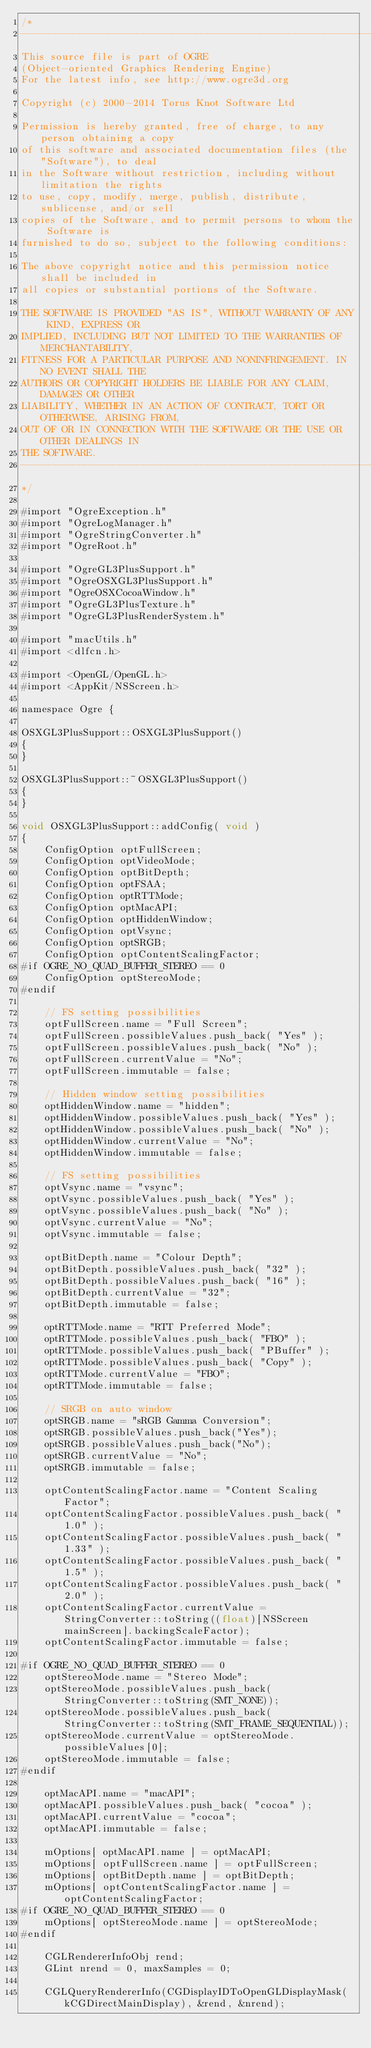<code> <loc_0><loc_0><loc_500><loc_500><_ObjectiveC_>/*
-----------------------------------------------------------------------------
This source file is part of OGRE
(Object-oriented Graphics Rendering Engine)
For the latest info, see http://www.ogre3d.org

Copyright (c) 2000-2014 Torus Knot Software Ltd

Permission is hereby granted, free of charge, to any person obtaining a copy
of this software and associated documentation files (the "Software"), to deal
in the Software without restriction, including without limitation the rights
to use, copy, modify, merge, publish, distribute, sublicense, and/or sell
copies of the Software, and to permit persons to whom the Software is
furnished to do so, subject to the following conditions:

The above copyright notice and this permission notice shall be included in
all copies or substantial portions of the Software.

THE SOFTWARE IS PROVIDED "AS IS", WITHOUT WARRANTY OF ANY KIND, EXPRESS OR
IMPLIED, INCLUDING BUT NOT LIMITED TO THE WARRANTIES OF MERCHANTABILITY,
FITNESS FOR A PARTICULAR PURPOSE AND NONINFRINGEMENT. IN NO EVENT SHALL THE
AUTHORS OR COPYRIGHT HOLDERS BE LIABLE FOR ANY CLAIM, DAMAGES OR OTHER
LIABILITY, WHETHER IN AN ACTION OF CONTRACT, TORT OR OTHERWISE, ARISING FROM,
OUT OF OR IN CONNECTION WITH THE SOFTWARE OR THE USE OR OTHER DEALINGS IN
THE SOFTWARE.
-----------------------------------------------------------------------------
*/

#import "OgreException.h"
#import "OgreLogManager.h"
#import "OgreStringConverter.h"
#import "OgreRoot.h"

#import "OgreGL3PlusSupport.h"
#import "OgreOSXGL3PlusSupport.h"
#import "OgreOSXCocoaWindow.h"
#import "OgreGL3PlusTexture.h"
#import "OgreGL3PlusRenderSystem.h"

#import "macUtils.h"
#import <dlfcn.h>

#import <OpenGL/OpenGL.h>
#import <AppKit/NSScreen.h>

namespace Ogre {

OSXGL3PlusSupport::OSXGL3PlusSupport()
{
}

OSXGL3PlusSupport::~OSXGL3PlusSupport()
{
}

void OSXGL3PlusSupport::addConfig( void )
{
	ConfigOption optFullScreen;
	ConfigOption optVideoMode;
	ConfigOption optBitDepth;
	ConfigOption optFSAA;
	ConfigOption optRTTMode;
    ConfigOption optMacAPI;
	ConfigOption optHiddenWindow;
	ConfigOption optVsync;
	ConfigOption optSRGB;
    ConfigOption optContentScalingFactor;
#if OGRE_NO_QUAD_BUFFER_STEREO == 0
	ConfigOption optStereoMode;
#endif

	// FS setting possibilities
	optFullScreen.name = "Full Screen";
	optFullScreen.possibleValues.push_back( "Yes" );
	optFullScreen.possibleValues.push_back( "No" );
	optFullScreen.currentValue = "No";
	optFullScreen.immutable = false;

    // Hidden window setting possibilities
	optHiddenWindow.name = "hidden";
	optHiddenWindow.possibleValues.push_back( "Yes" );
	optHiddenWindow.possibleValues.push_back( "No" );
	optHiddenWindow.currentValue = "No";
	optHiddenWindow.immutable = false;

    // FS setting possibilities
	optVsync.name = "vsync";
	optVsync.possibleValues.push_back( "Yes" );
	optVsync.possibleValues.push_back( "No" );
	optVsync.currentValue = "No";
	optVsync.immutable = false;

	optBitDepth.name = "Colour Depth";
	optBitDepth.possibleValues.push_back( "32" );
	optBitDepth.possibleValues.push_back( "16" );
	optBitDepth.currentValue = "32";
	optBitDepth.immutable = false;

    optRTTMode.name = "RTT Preferred Mode";
	optRTTMode.possibleValues.push_back( "FBO" );
	optRTTMode.possibleValues.push_back( "PBuffer" );
	optRTTMode.possibleValues.push_back( "Copy" );
	optRTTMode.currentValue = "FBO";
	optRTTMode.immutable = false;

	// SRGB on auto window
	optSRGB.name = "sRGB Gamma Conversion";
	optSRGB.possibleValues.push_back("Yes");
	optSRGB.possibleValues.push_back("No");
	optSRGB.currentValue = "No";
	optSRGB.immutable = false;

    optContentScalingFactor.name = "Content Scaling Factor";
    optContentScalingFactor.possibleValues.push_back( "1.0" );
    optContentScalingFactor.possibleValues.push_back( "1.33" );
    optContentScalingFactor.possibleValues.push_back( "1.5" );
    optContentScalingFactor.possibleValues.push_back( "2.0" );
    optContentScalingFactor.currentValue = StringConverter::toString((float)[NSScreen mainScreen].backingScaleFactor);
    optContentScalingFactor.immutable = false;

#if OGRE_NO_QUAD_BUFFER_STEREO == 0
	optStereoMode.name = "Stereo Mode";
	optStereoMode.possibleValues.push_back(StringConverter::toString(SMT_NONE));
	optStereoMode.possibleValues.push_back(StringConverter::toString(SMT_FRAME_SEQUENTIAL));
	optStereoMode.currentValue = optStereoMode.possibleValues[0];
	optStereoMode.immutable = false;
#endif

    optMacAPI.name = "macAPI";
    optMacAPI.possibleValues.push_back( "cocoa" );
	optMacAPI.currentValue = "cocoa";
    optMacAPI.immutable = false;

    mOptions[ optMacAPI.name ] = optMacAPI;
    mOptions[ optFullScreen.name ] = optFullScreen;
	mOptions[ optBitDepth.name ] = optBitDepth;
    mOptions[ optContentScalingFactor.name ] = optContentScalingFactor;
#if OGRE_NO_QUAD_BUFFER_STEREO == 0
	mOptions[ optStereoMode.name ] = optStereoMode;
#endif

	CGLRendererInfoObj rend;
	GLint nrend = 0, maxSamples = 0;

	CGLQueryRendererInfo(CGDisplayIDToOpenGLDisplayMask(kCGDirectMainDisplay), &rend, &nrend);</code> 